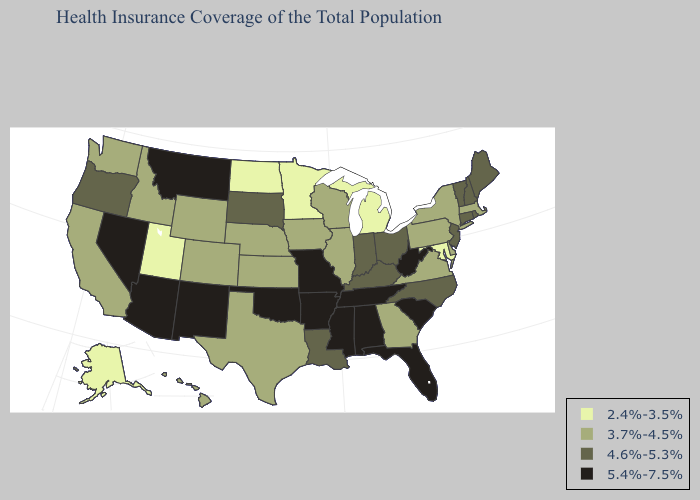Among the states that border Illinois , does Wisconsin have the lowest value?
Concise answer only. Yes. Name the states that have a value in the range 2.4%-3.5%?
Quick response, please. Alaska, Maryland, Michigan, Minnesota, North Dakota, Utah. What is the highest value in states that border California?
Quick response, please. 5.4%-7.5%. Does New Hampshire have the lowest value in the USA?
Keep it brief. No. Which states hav the highest value in the Northeast?
Quick response, please. Connecticut, Maine, New Hampshire, New Jersey, Rhode Island, Vermont. What is the lowest value in states that border Connecticut?
Be succinct. 3.7%-4.5%. Is the legend a continuous bar?
Be succinct. No. Which states have the lowest value in the USA?
Short answer required. Alaska, Maryland, Michigan, Minnesota, North Dakota, Utah. What is the lowest value in states that border Minnesota?
Be succinct. 2.4%-3.5%. Does Oregon have the highest value in the USA?
Answer briefly. No. Does Wisconsin have a higher value than Rhode Island?
Give a very brief answer. No. What is the value of Tennessee?
Short answer required. 5.4%-7.5%. What is the highest value in the Northeast ?
Write a very short answer. 4.6%-5.3%. Does Oregon have a lower value than North Dakota?
Write a very short answer. No. What is the lowest value in the USA?
Write a very short answer. 2.4%-3.5%. 